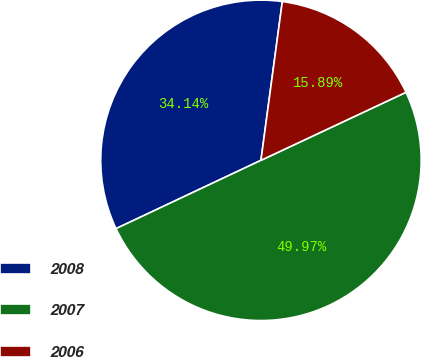<chart> <loc_0><loc_0><loc_500><loc_500><pie_chart><fcel>2008<fcel>2007<fcel>2006<nl><fcel>34.14%<fcel>49.97%<fcel>15.89%<nl></chart> 